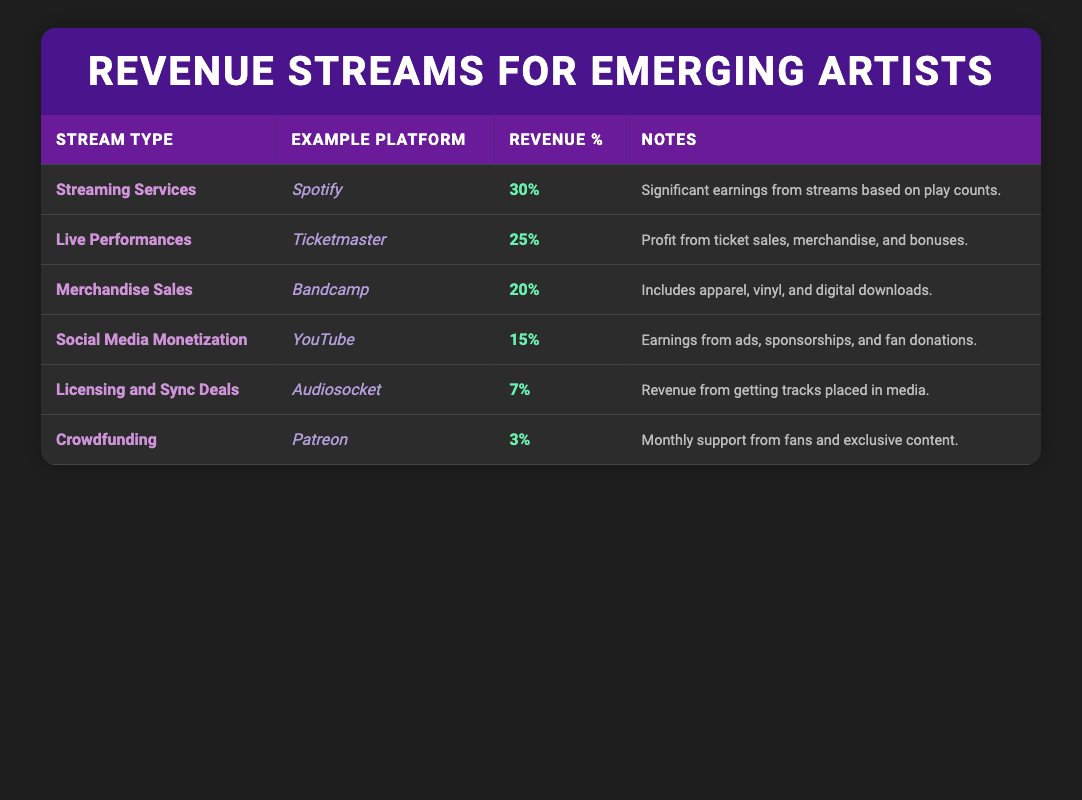What is the highest revenue stream type listed? The revenue streams are ranked by their revenue percentages. By reviewing the "Revenue %" column, Streaming Services has the highest percentage at 30%.
Answer: Streaming Services What percentage of revenue comes from licensing and sync deals? By locating the "Licensing and Sync Deals" row in the table, we find that the revenue percentage for this stream is listed as 7%.
Answer: 7% What is the total revenue percentage from live performances and merchandise sales combined? Adding the percentages from the "Live Performances" (25%) and "Merchandise Sales" (20%) gives a total of 25 + 20 = 45%.
Answer: 45% Is social media monetization a significant revenue stream compared to crowdfunding? By comparing the percentages, social media monetization is at 15%, while crowdfunding is at 3%. Since 15% is greater than 3%, social media monetization is indeed significant compared to crowdfunding.
Answer: Yes What revenue stream represents 20% of total earnings? Observing the table, "Merchandise Sales" is specifically listed with a revenue percentage of 20%.
Answer: Merchandise Sales If an artist earns $1,000 from streaming services, how much would they earn from live performances based on the percentage difference? The difference in revenue percentages between streaming services (30%) and live performances (25%) is 5%. If the artist earns $1,000 from streaming services, the calculation would be $1,000 * (25/30) = $833.33 from live performances, which is simply taking 25% of their earnings out of the 30% share.
Answer: $833.33 What revenue stream has the least earnings potential? The table shows all stream types sorted by their revenue percentages. Crowdfunding, listed last with just 3%, has the least earning potential.
Answer: Crowdfunding If an artist sells $500 worth of merchandise, what would their total revenue from this stream be? Since merchandise sales account for 20% of total earnings, if an artist's sales in this category are $500, then they earn exactly $500 - that is the sales amount given, not based on a percentage for this question.
Answer: $500 